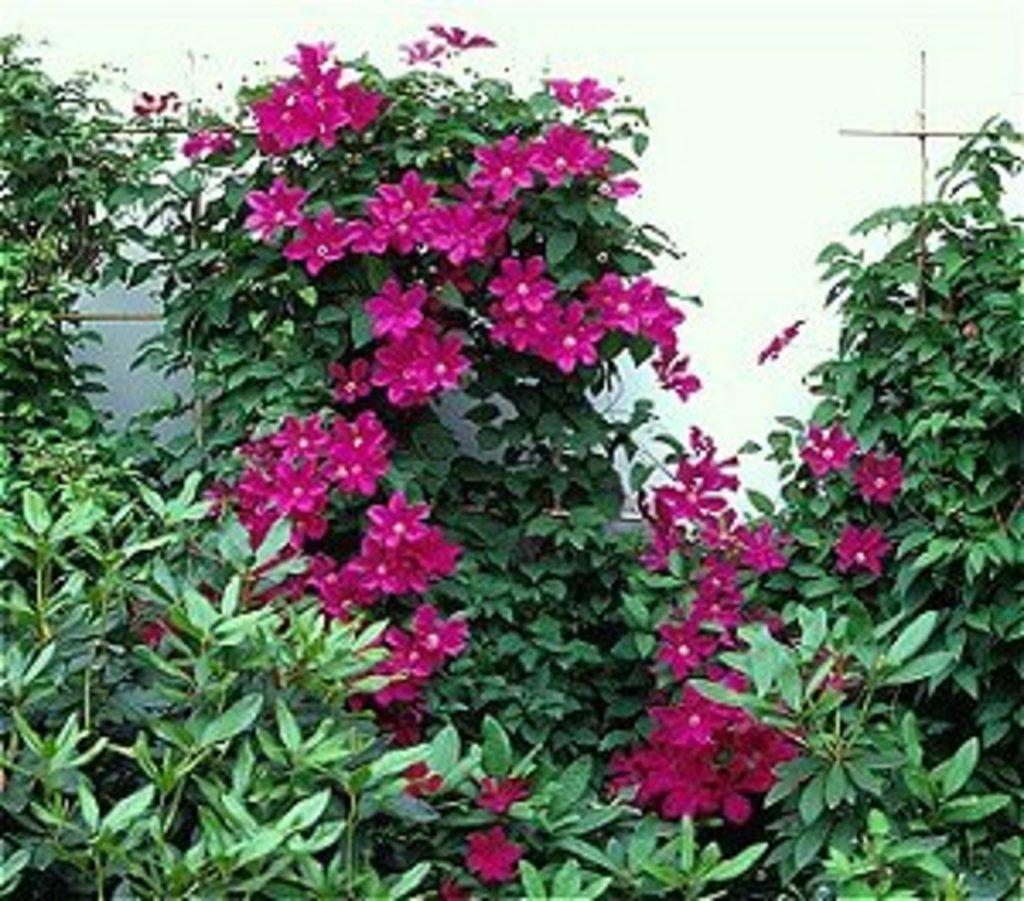What type of plant elements can be seen in the image? There are flowers, leaves, and stems in the image. What is the appearance of the background in the image? The background of the image is blurry. Can you describe any objects visible in the background? There are objects visible in the background, but their specific details cannot be discerned due to the blurriness. How many pigs can be seen in the image? There are no pigs present in the image. What type of crack is visible on the leaves in the image? There are no cracks visible on the leaves in the image. 